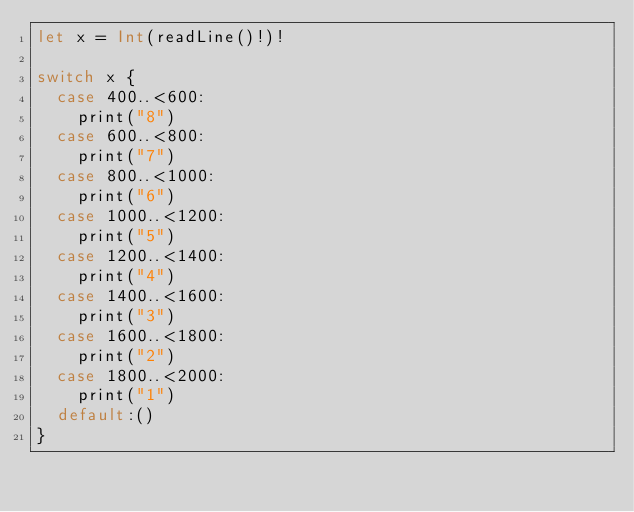<code> <loc_0><loc_0><loc_500><loc_500><_Swift_>let x = Int(readLine()!)!

switch x {
  case 400..<600:
  	print("8")
  case 600..<800:
    print("7")
  case 800..<1000:
    print("6")
  case 1000..<1200:
    print("5")
  case 1200..<1400:
    print("4")
  case 1400..<1600:
    print("3")
  case 1600..<1800:
    print("2")
  case 1800..<2000:
    print("1")
  default:()
}</code> 